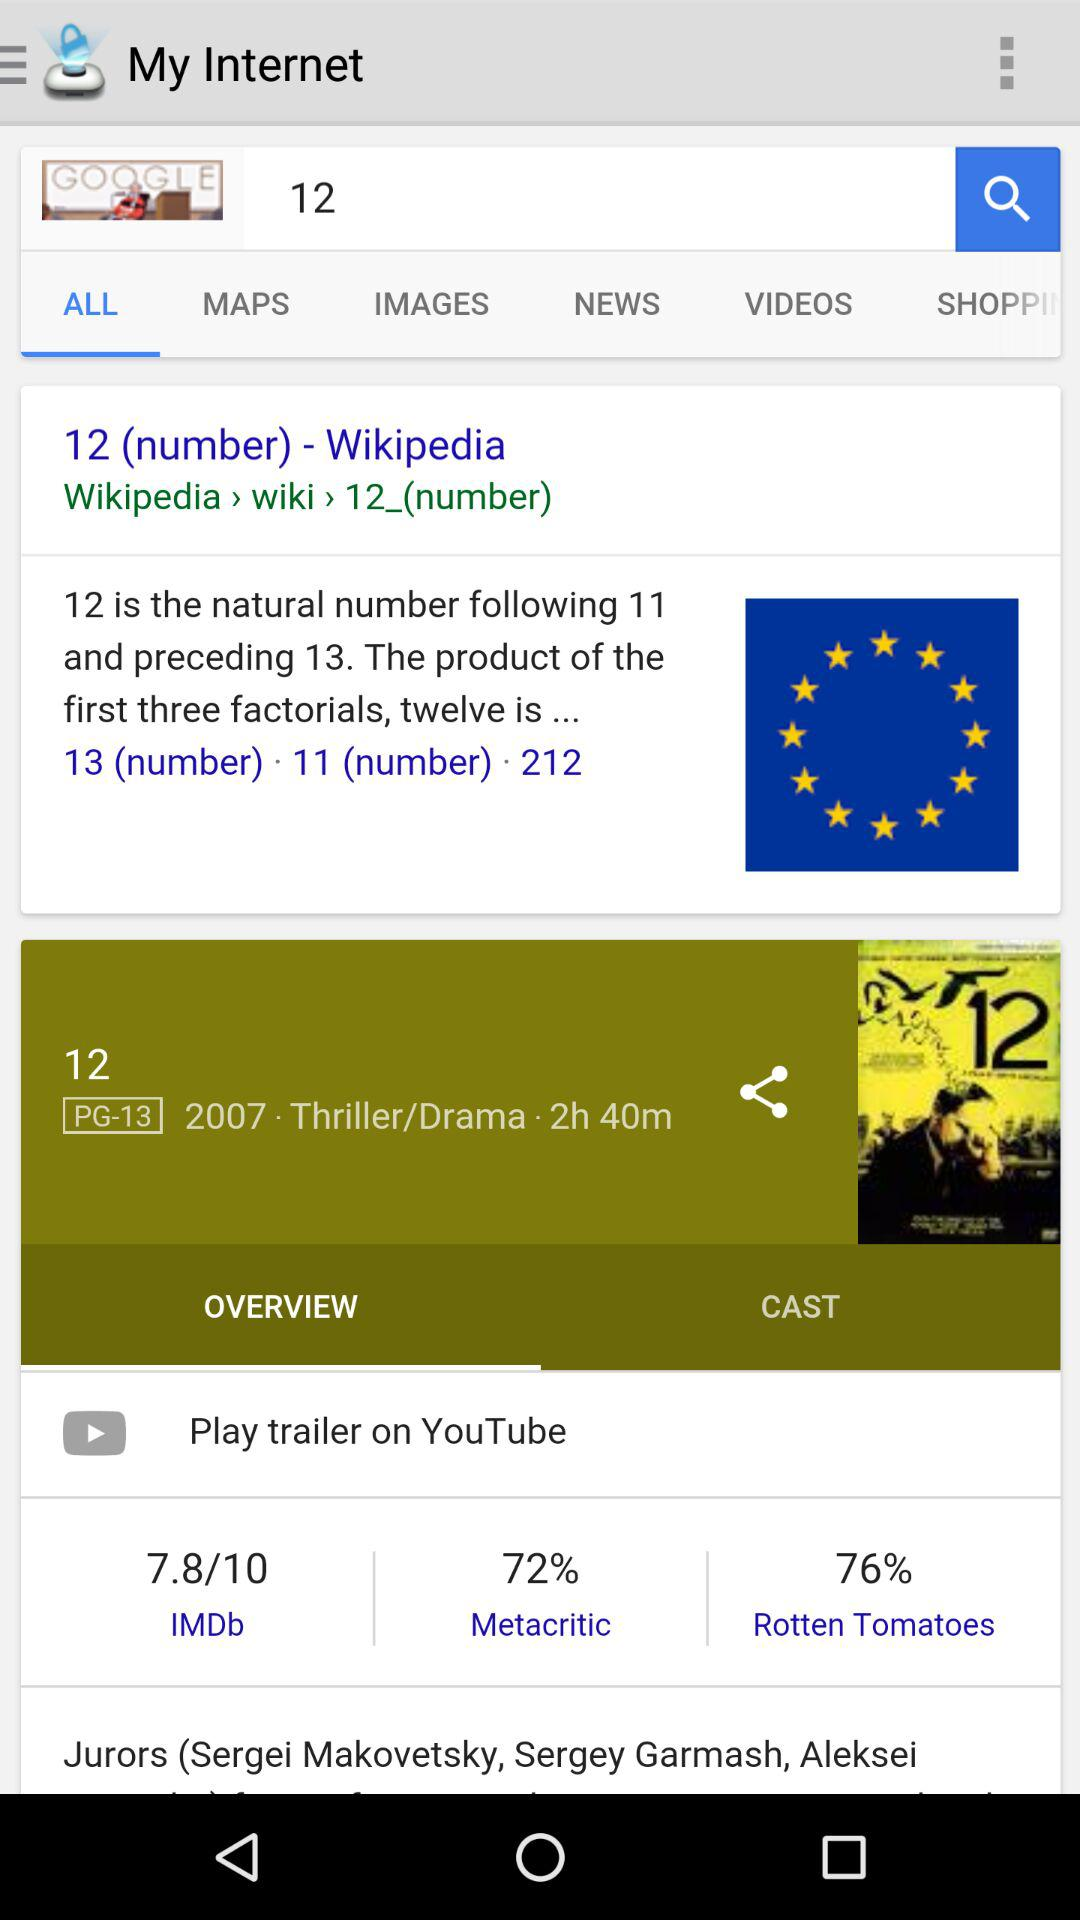What is the IMDb rating? The IMDb rating is 7.8. 